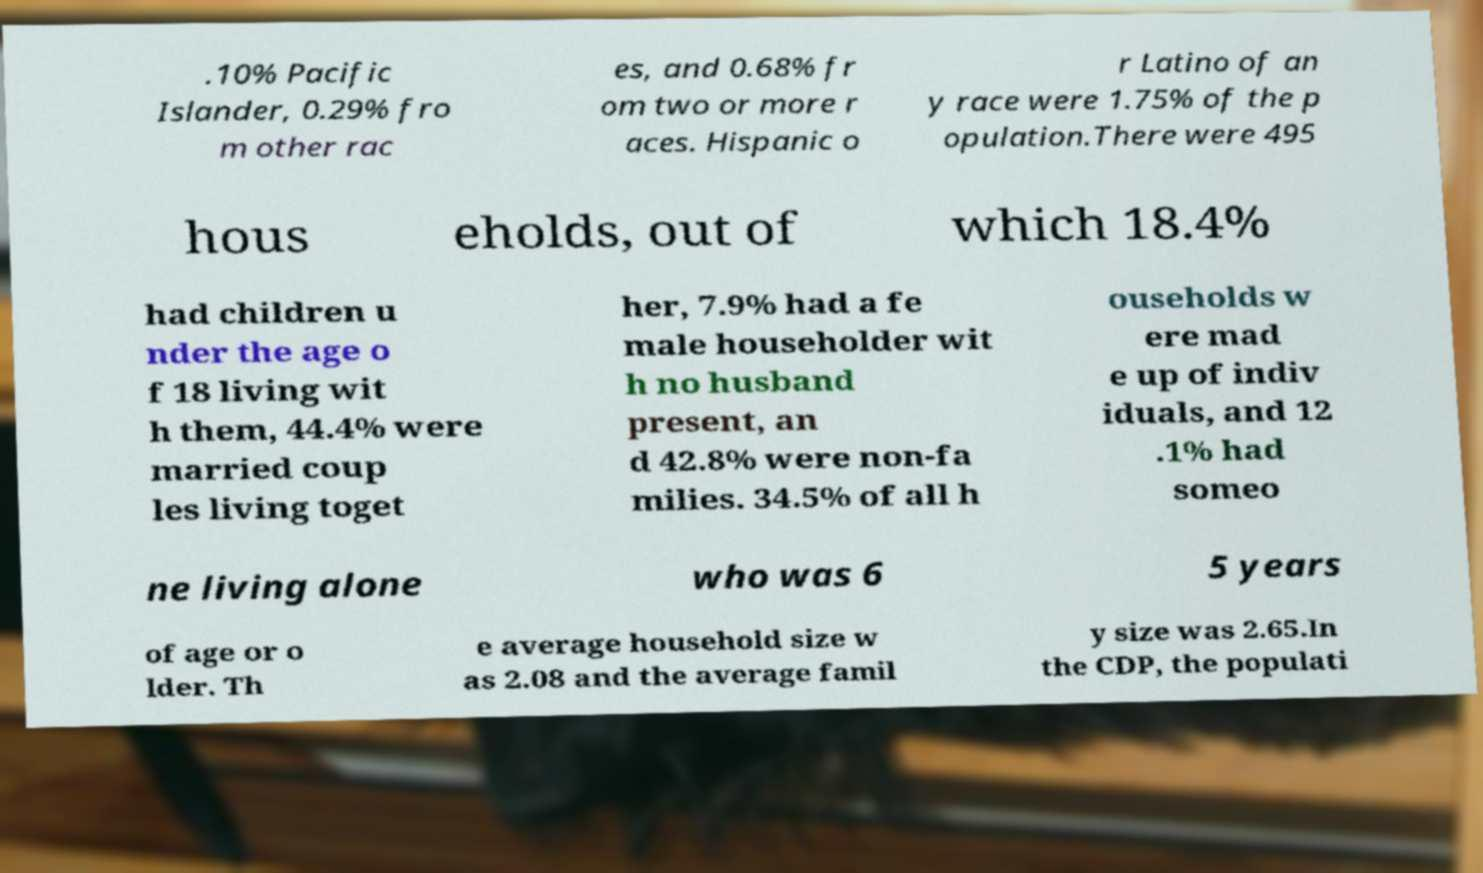Could you extract and type out the text from this image? .10% Pacific Islander, 0.29% fro m other rac es, and 0.68% fr om two or more r aces. Hispanic o r Latino of an y race were 1.75% of the p opulation.There were 495 hous eholds, out of which 18.4% had children u nder the age o f 18 living wit h them, 44.4% were married coup les living toget her, 7.9% had a fe male householder wit h no husband present, an d 42.8% were non-fa milies. 34.5% of all h ouseholds w ere mad e up of indiv iduals, and 12 .1% had someo ne living alone who was 6 5 years of age or o lder. Th e average household size w as 2.08 and the average famil y size was 2.65.In the CDP, the populati 